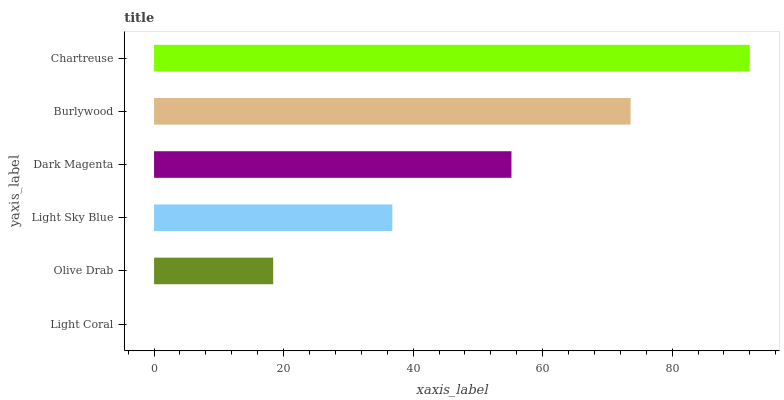Is Light Coral the minimum?
Answer yes or no. Yes. Is Chartreuse the maximum?
Answer yes or no. Yes. Is Olive Drab the minimum?
Answer yes or no. No. Is Olive Drab the maximum?
Answer yes or no. No. Is Olive Drab greater than Light Coral?
Answer yes or no. Yes. Is Light Coral less than Olive Drab?
Answer yes or no. Yes. Is Light Coral greater than Olive Drab?
Answer yes or no. No. Is Olive Drab less than Light Coral?
Answer yes or no. No. Is Dark Magenta the high median?
Answer yes or no. Yes. Is Light Sky Blue the low median?
Answer yes or no. Yes. Is Chartreuse the high median?
Answer yes or no. No. Is Light Coral the low median?
Answer yes or no. No. 